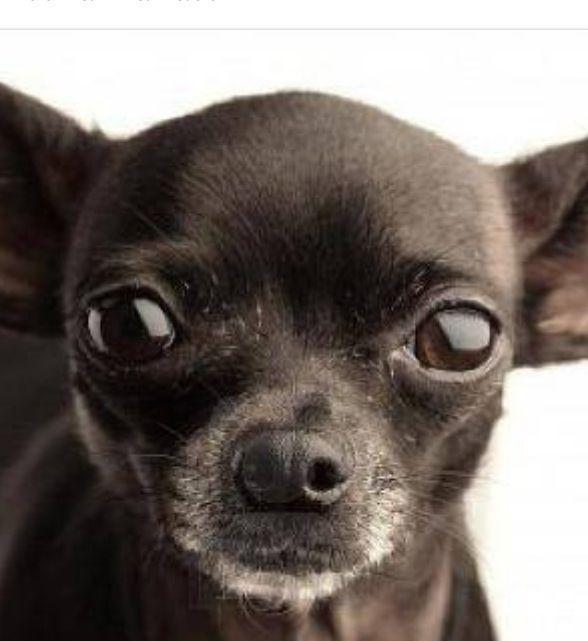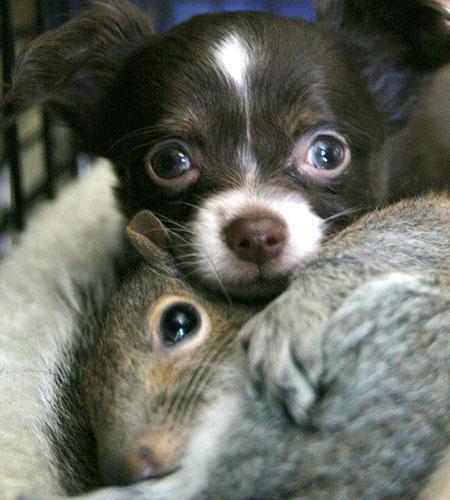The first image is the image on the left, the second image is the image on the right. For the images displayed, is the sentence "One of the images shows a dog with its tongue sticking out." factually correct? Answer yes or no. No. The first image is the image on the left, the second image is the image on the right. For the images displayed, is the sentence "Two little dogs have eyes wide open, but only one of them is showing his tongue." factually correct? Answer yes or no. No. The first image is the image on the left, the second image is the image on the right. Assess this claim about the two images: "An image shows a dog with its tongue sticking out.". Correct or not? Answer yes or no. No. 